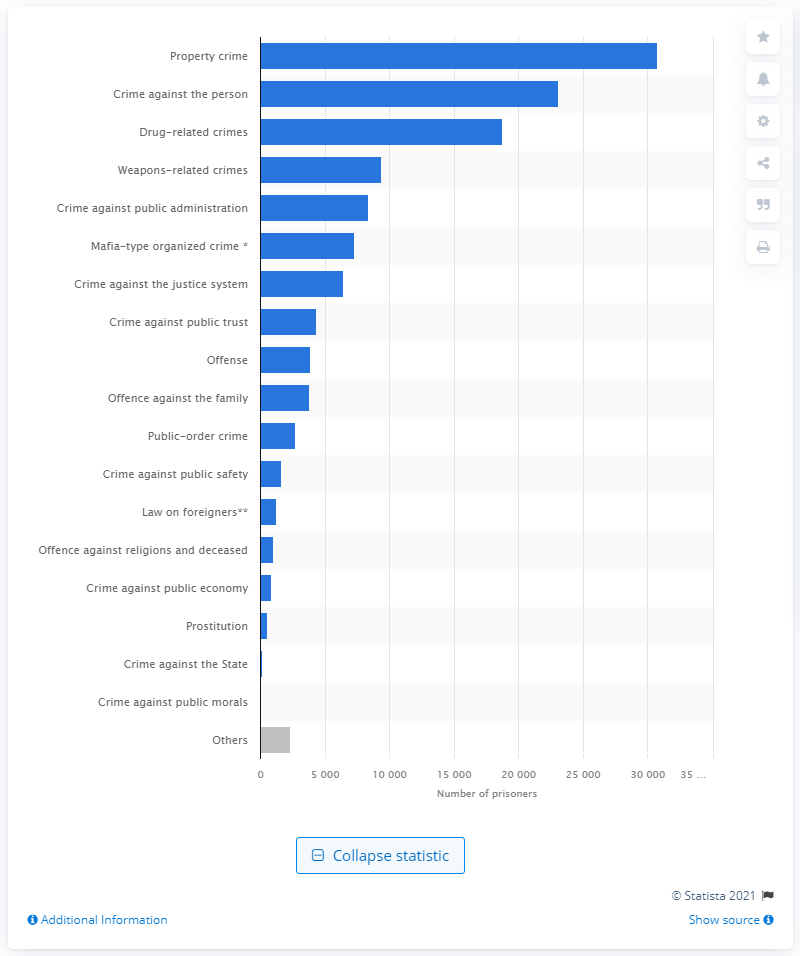Draw attention to some important aspects in this diagram. As of December 2020, a total of 23,095 individuals were convicted of committing a crime against a person. 